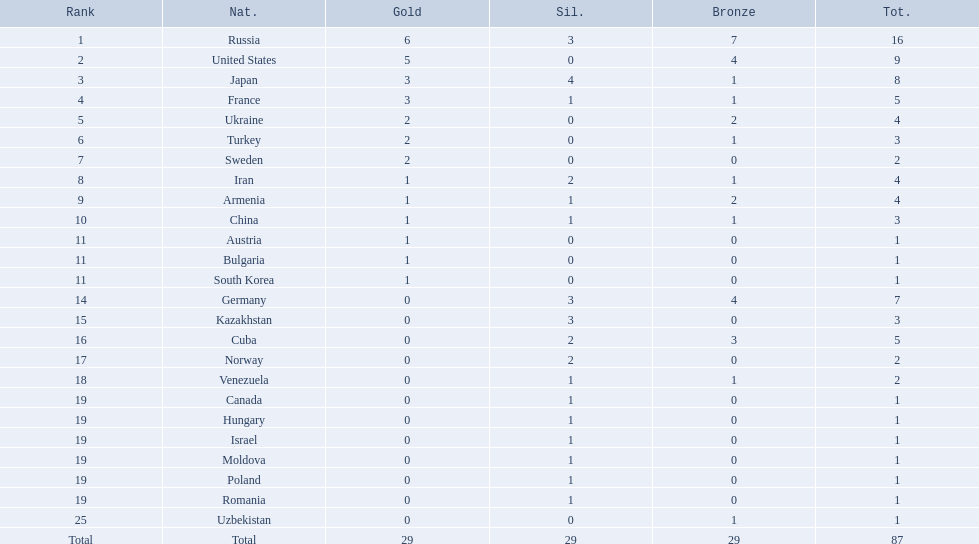Where did iran rank? 8. Where did germany rank? 14. Which of those did make it into the top 10 rank? Germany. Parse the full table. {'header': ['Rank', 'Nat.', 'Gold', 'Sil.', 'Bronze', 'Tot.'], 'rows': [['1', 'Russia', '6', '3', '7', '16'], ['2', 'United States', '5', '0', '4', '9'], ['3', 'Japan', '3', '4', '1', '8'], ['4', 'France', '3', '1', '1', '5'], ['5', 'Ukraine', '2', '0', '2', '4'], ['6', 'Turkey', '2', '0', '1', '3'], ['7', 'Sweden', '2', '0', '0', '2'], ['8', 'Iran', '1', '2', '1', '4'], ['9', 'Armenia', '1', '1', '2', '4'], ['10', 'China', '1', '1', '1', '3'], ['11', 'Austria', '1', '0', '0', '1'], ['11', 'Bulgaria', '1', '0', '0', '1'], ['11', 'South Korea', '1', '0', '0', '1'], ['14', 'Germany', '0', '3', '4', '7'], ['15', 'Kazakhstan', '0', '3', '0', '3'], ['16', 'Cuba', '0', '2', '3', '5'], ['17', 'Norway', '0', '2', '0', '2'], ['18', 'Venezuela', '0', '1', '1', '2'], ['19', 'Canada', '0', '1', '0', '1'], ['19', 'Hungary', '0', '1', '0', '1'], ['19', 'Israel', '0', '1', '0', '1'], ['19', 'Moldova', '0', '1', '0', '1'], ['19', 'Poland', '0', '1', '0', '1'], ['19', 'Romania', '0', '1', '0', '1'], ['25', 'Uzbekistan', '0', '0', '1', '1'], ['Total', 'Total', '29', '29', '29', '87']]} What was iran's ranking? 8. What was germany's ranking? 14. Between iran and germany, which was not in the top 10? Germany. 